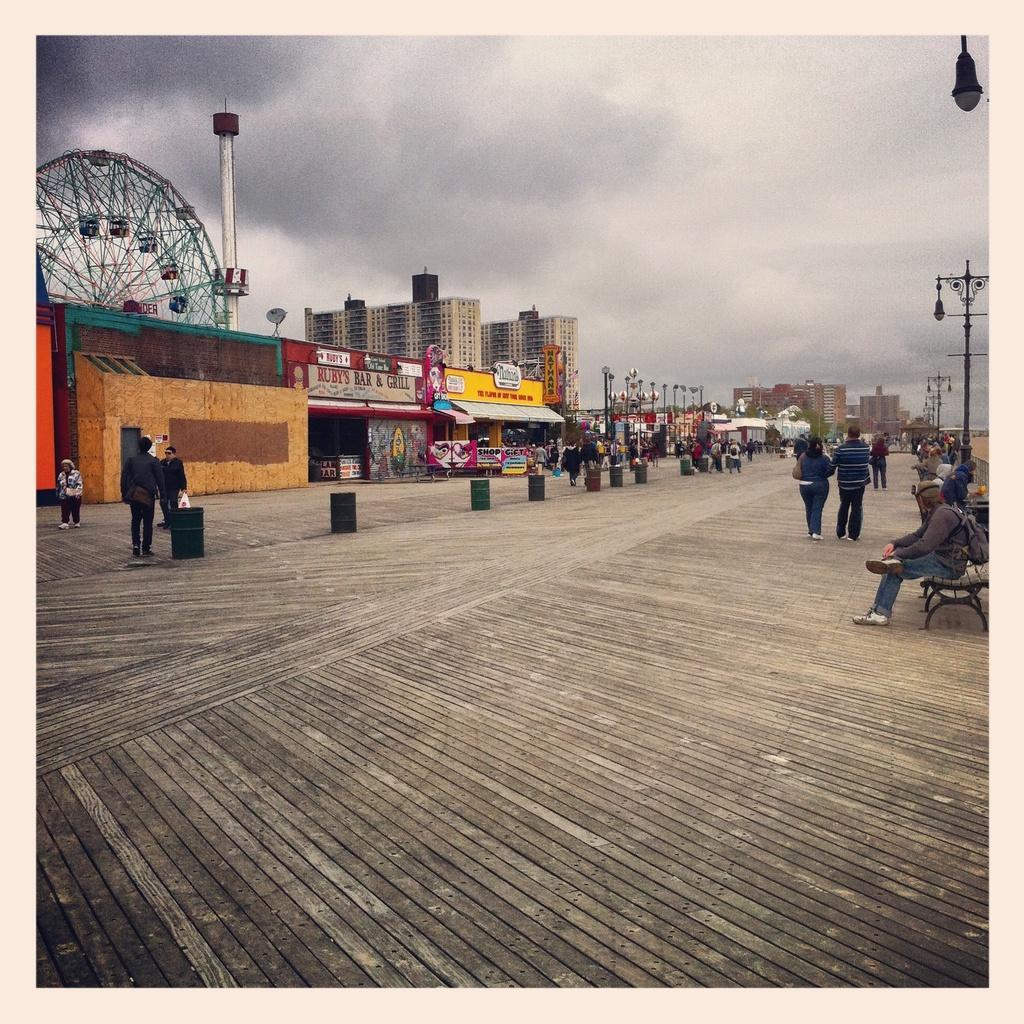Can you describe this image briefly? This looks like an edited image. I can see few people standing and few people walking. These are the buildings and the shops with the name boards. These look like the iron barrels. On the right side of the image, I can see few people sitting on the benches. This looks like the wooden pathway. On the left side of the image, I can see a giant wheel. This is the sky. I think these are the light poles. 